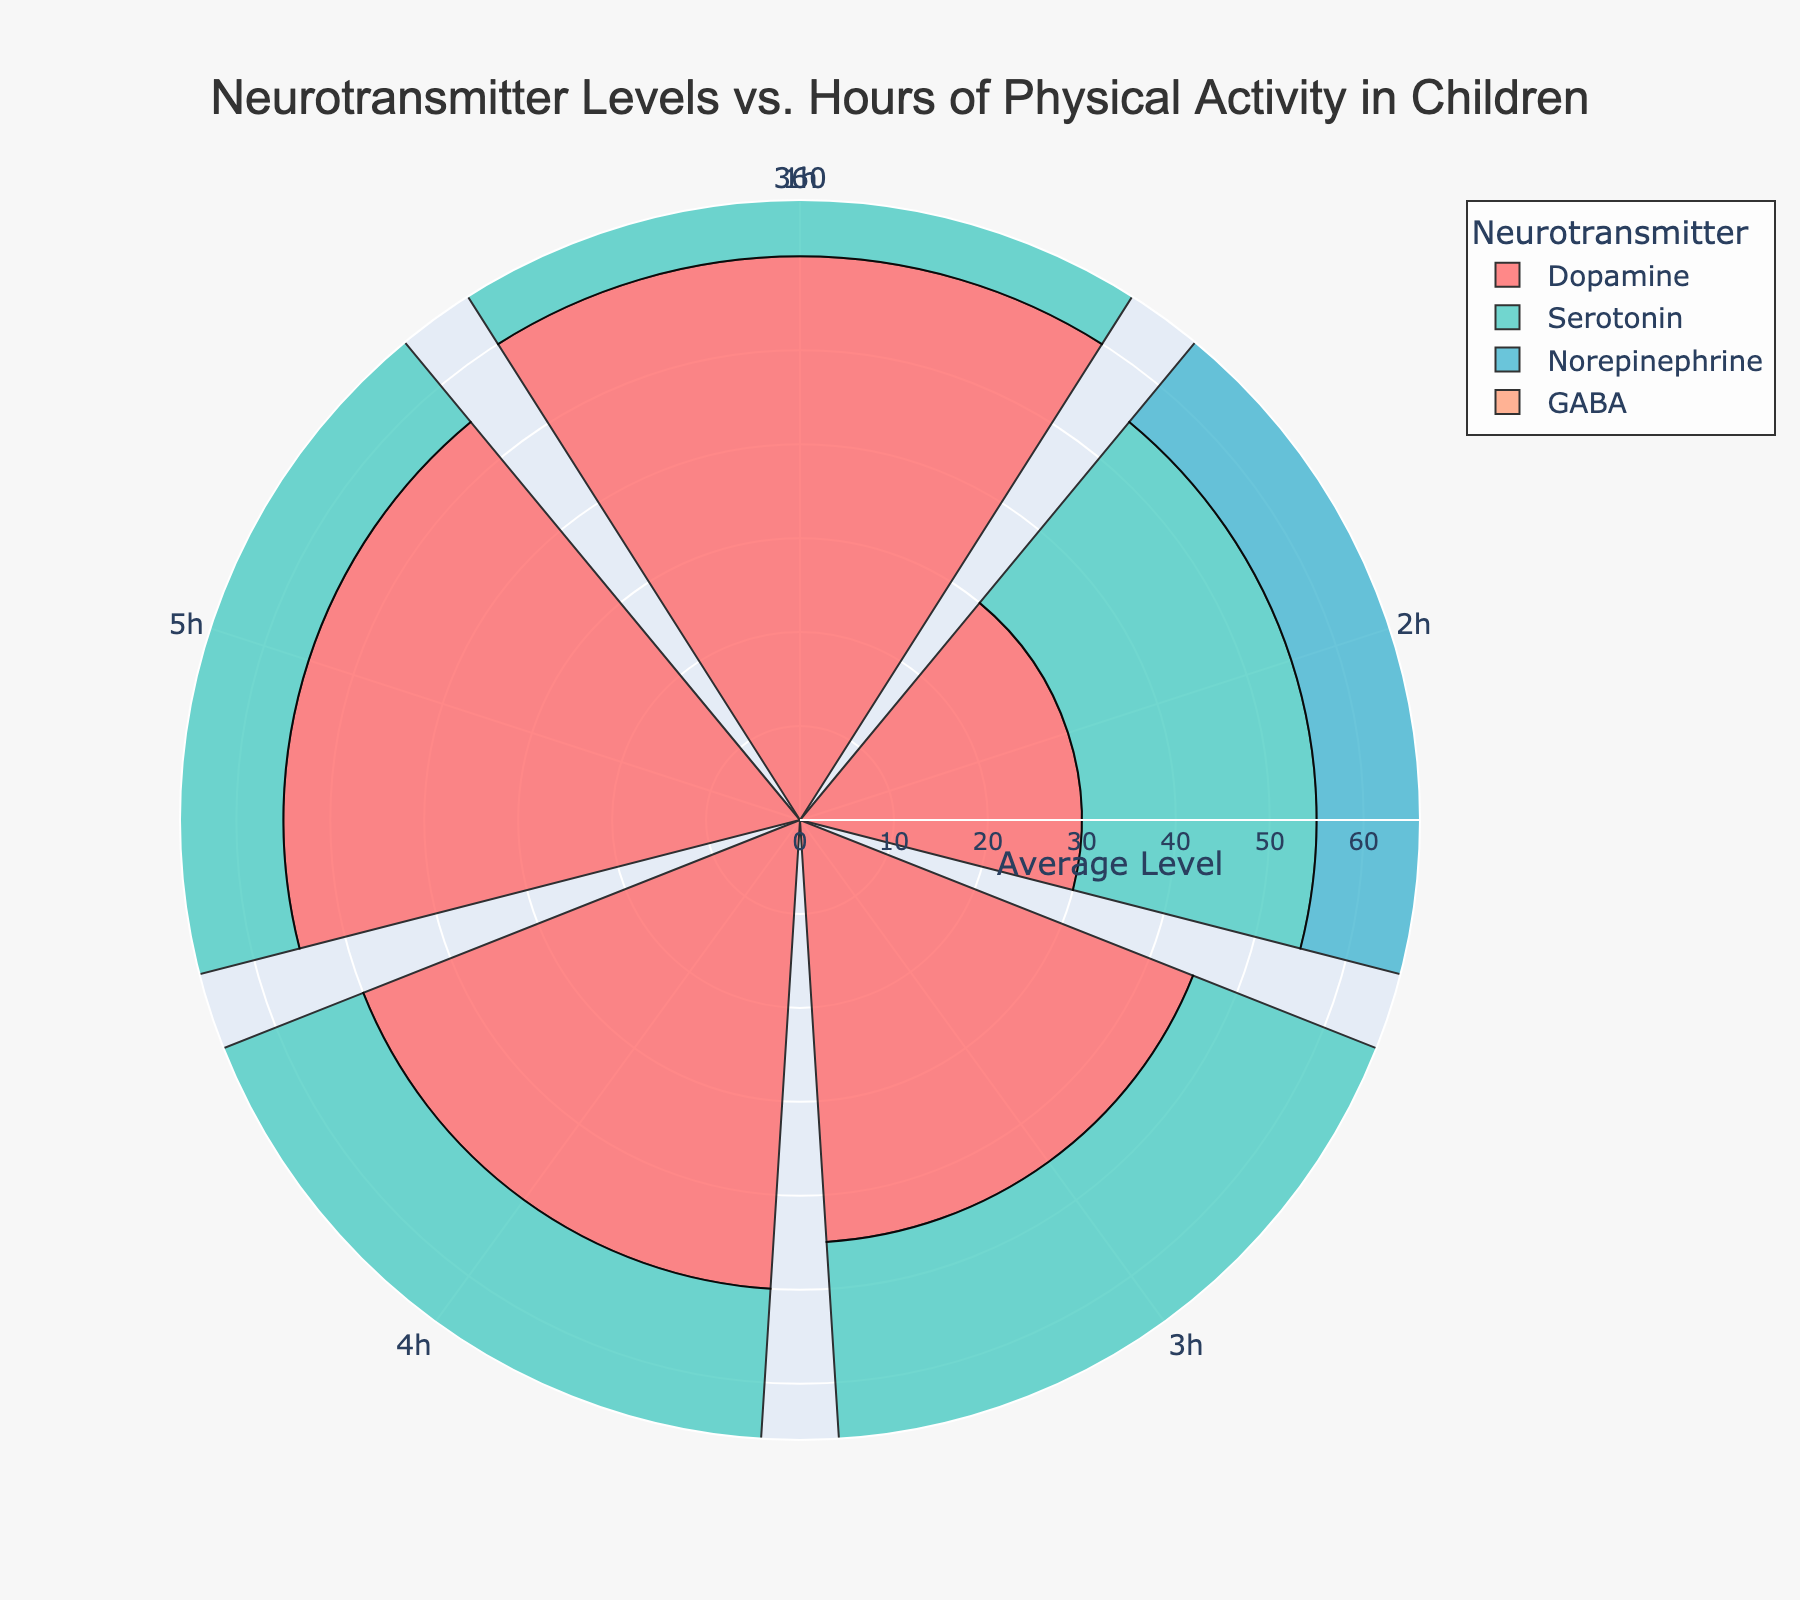What's the title of the figure? The title is usually at the top of the figure, it provides a summary of what the figure represents.
Answer: Neurotransmitter Levels vs. Hours of Physical Activity in Children How many different neurotransmitters are displayed in the figure? The legend lists all the different neurotransmitters represented in the figure.
Answer: Four What is the average dopamine level at 3 hours of physical activity? Find the bar representing dopamine at the 3-hour mark and note its radial value.
Answer: 50 Which neurotransmitter shows the lowest average level at 1 hour of physical activity? Compare the radial values of the bars at the 1-hour mark for all neurotransmitters.
Answer: GABA How does the average serotonin level at 5 hours compare to that at 1 hour? Note the average levels of serotonin at 1 hour and 5 hours, then calculate the difference. The 5-hour level is - the 1-hour level.
Answer: 52 - 25 = 27 What's the average level increment of norepinephrine from 1 to 5 hours of physical activity? Find the average levels of norepinephrine at 1 hour and 5 hours, calculate the difference.
Answer: 50 - 20 = 30 Which neurotransmitter shows the highest increase in average level from 1 to 5 hours? Calculate the difference in average levels at 1 and 5 hours for all neurotransmitters, then compare them.
Answer: Dopamine (60 - 30 = 30) What is the most common radial value range of neurotransmitter levels at 5 hours of activity? Observe the radial values at the 5-hour mark for all neurotransmitters and identify the range that appears most frequently.
Answer: 50-60 Between which hours does GABA show the most significant increase in average level? Analyze the radial values for GABA across different hours and identify where the biggest jump occurs.
Answer: Between 2 and 3 hours In terms of neurotransmitter levels, which neurotransmitter benefits the most from increasing physical activity from 1 hour to 5 hours? Look at the differences in radial values from 1 hour to 5 hours for each neurotransmitter and identify the maximum difference.
Answer: Dopamine 